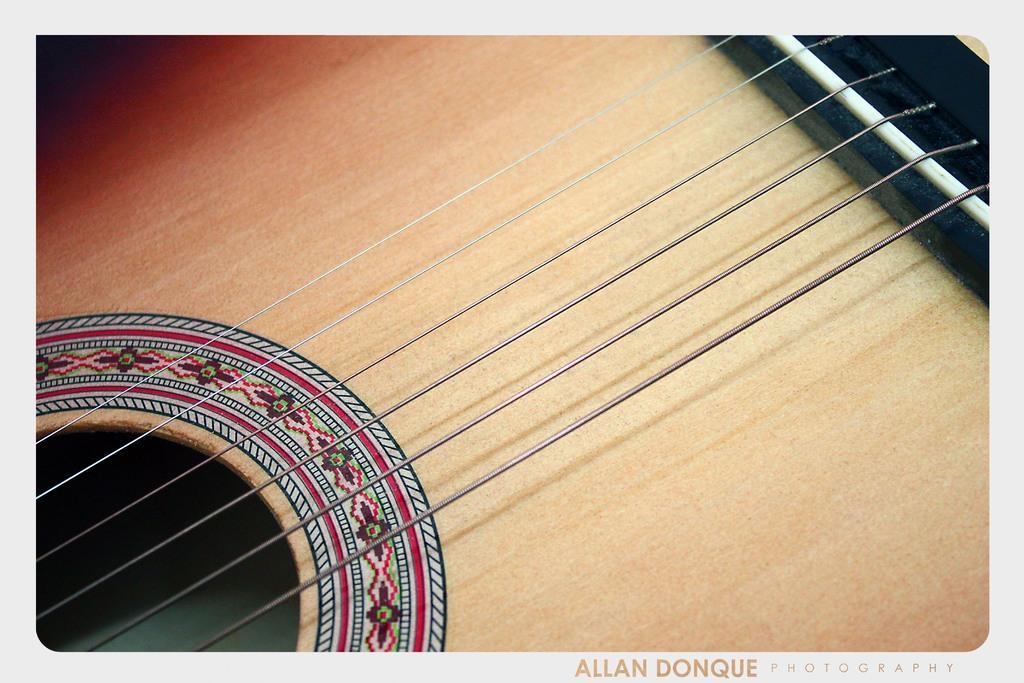Please provide a concise description of this image. In this image I can see a guitar. 